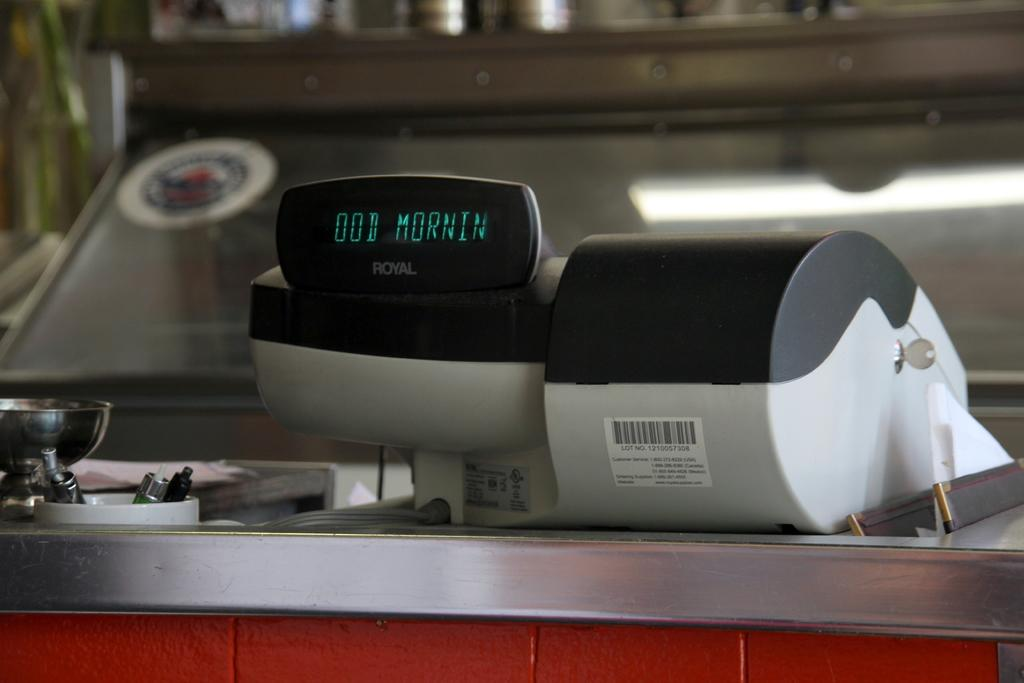<image>
Share a concise interpretation of the image provided. A cash register with the ood mornin on the screen. 